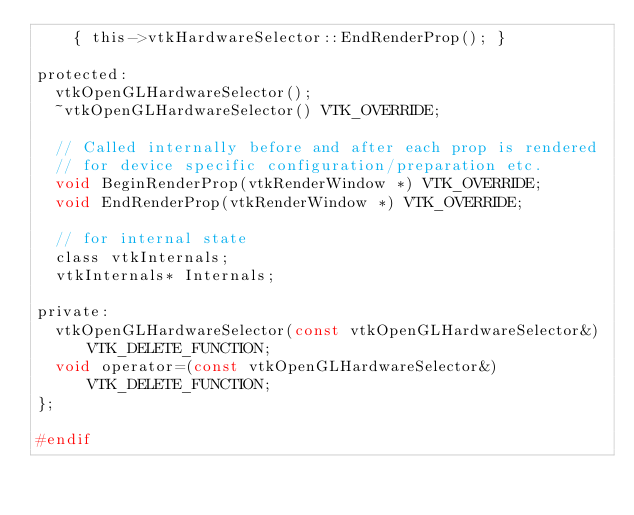Convert code to text. <code><loc_0><loc_0><loc_500><loc_500><_C_>    { this->vtkHardwareSelector::EndRenderProp(); }

protected:
  vtkOpenGLHardwareSelector();
  ~vtkOpenGLHardwareSelector() VTK_OVERRIDE;

  // Called internally before and after each prop is rendered
  // for device specific configuration/preparation etc.
  void BeginRenderProp(vtkRenderWindow *) VTK_OVERRIDE;
  void EndRenderProp(vtkRenderWindow *) VTK_OVERRIDE;

  // for internal state
  class vtkInternals;
  vtkInternals* Internals;

private:
  vtkOpenGLHardwareSelector(const vtkOpenGLHardwareSelector&) VTK_DELETE_FUNCTION;
  void operator=(const vtkOpenGLHardwareSelector&) VTK_DELETE_FUNCTION;
};

#endif
</code> 